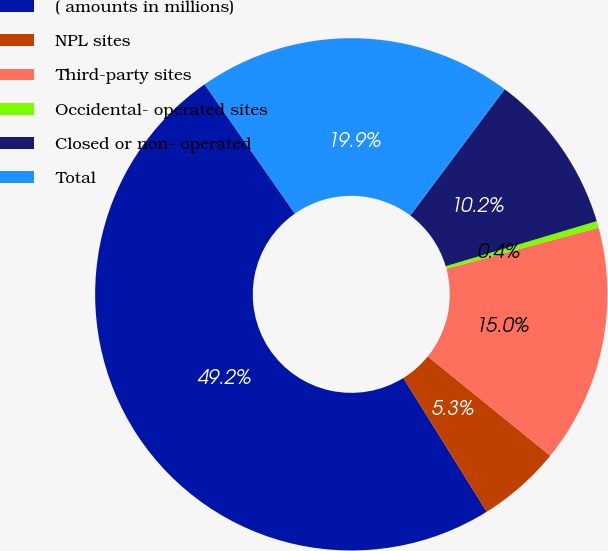Convert chart to OTSL. <chart><loc_0><loc_0><loc_500><loc_500><pie_chart><fcel>( amounts in millions)<fcel>NPL sites<fcel>Third-party sites<fcel>Occidental- operated sites<fcel>Closed or non- operated<fcel>Total<nl><fcel>49.17%<fcel>5.29%<fcel>15.04%<fcel>0.42%<fcel>10.17%<fcel>19.92%<nl></chart> 